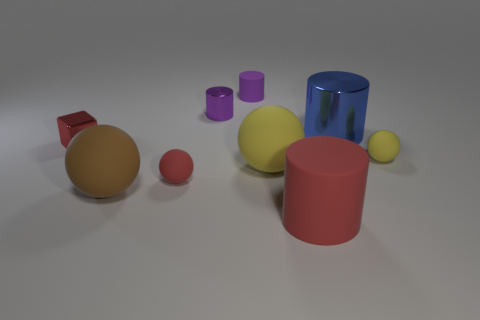Are the objects in the image all solid, or are some hollow? Visually assessing the image, it's not possible to conclusively determine if the objects are solid or hollow without additional context or information about the materials. 